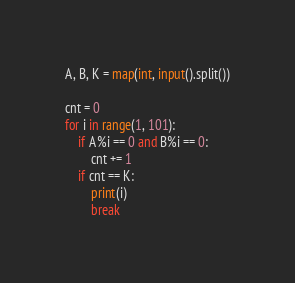Convert code to text. <code><loc_0><loc_0><loc_500><loc_500><_Python_>A, B, K = map(int, input().split())

cnt = 0
for i in range(1, 101):
    if A%i == 0 and B%i == 0:
        cnt += 1
    if cnt == K:
        print(i)
        break </code> 